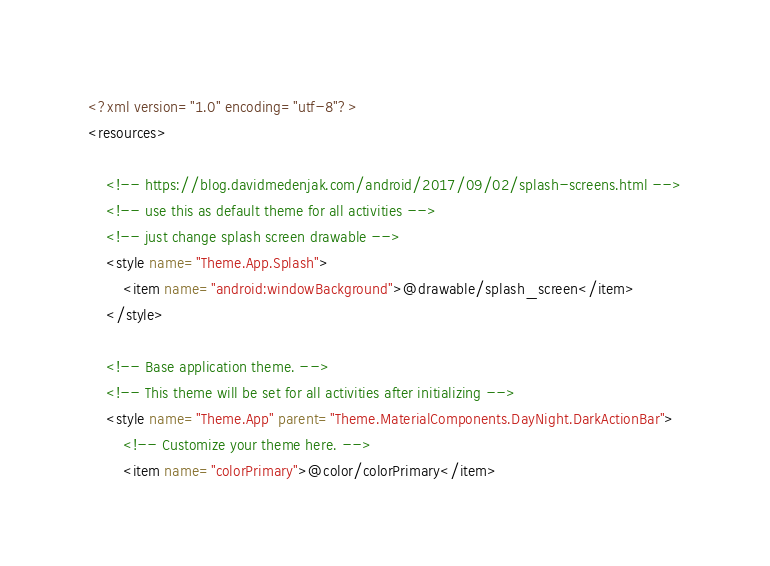<code> <loc_0><loc_0><loc_500><loc_500><_XML_><?xml version="1.0" encoding="utf-8"?>
<resources>

    <!-- https://blog.davidmedenjak.com/android/2017/09/02/splash-screens.html -->
    <!-- use this as default theme for all activities -->
    <!-- just change splash screen drawable -->
    <style name="Theme.App.Splash">
        <item name="android:windowBackground">@drawable/splash_screen</item>
    </style>

    <!-- Base application theme. -->
    <!-- This theme will be set for all activities after initializing -->
    <style name="Theme.App" parent="Theme.MaterialComponents.DayNight.DarkActionBar">
        <!-- Customize your theme here. -->
        <item name="colorPrimary">@color/colorPrimary</item></code> 